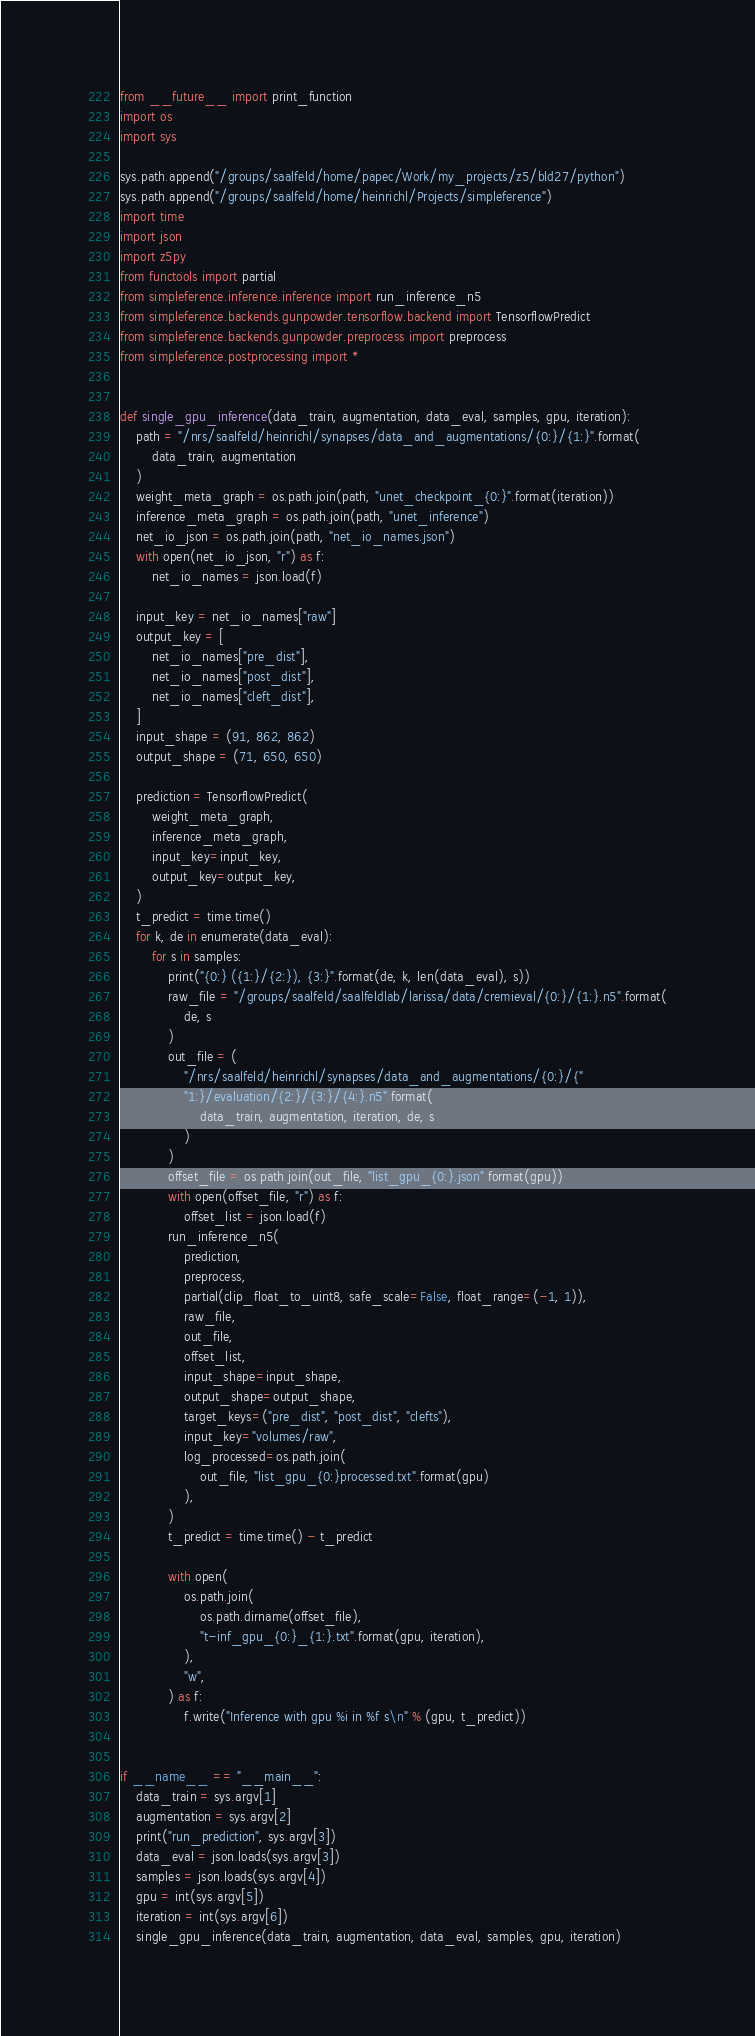<code> <loc_0><loc_0><loc_500><loc_500><_Python_>from __future__ import print_function
import os
import sys

sys.path.append("/groups/saalfeld/home/papec/Work/my_projects/z5/bld27/python")
sys.path.append("/groups/saalfeld/home/heinrichl/Projects/simpleference")
import time
import json
import z5py
from functools import partial
from simpleference.inference.inference import run_inference_n5
from simpleference.backends.gunpowder.tensorflow.backend import TensorflowPredict
from simpleference.backends.gunpowder.preprocess import preprocess
from simpleference.postprocessing import *


def single_gpu_inference(data_train, augmentation, data_eval, samples, gpu, iteration):
    path = "/nrs/saalfeld/heinrichl/synapses/data_and_augmentations/{0:}/{1:}".format(
        data_train, augmentation
    )
    weight_meta_graph = os.path.join(path, "unet_checkpoint_{0:}".format(iteration))
    inference_meta_graph = os.path.join(path, "unet_inference")
    net_io_json = os.path.join(path, "net_io_names.json")
    with open(net_io_json, "r") as f:
        net_io_names = json.load(f)

    input_key = net_io_names["raw"]
    output_key = [
        net_io_names["pre_dist"],
        net_io_names["post_dist"],
        net_io_names["cleft_dist"],
    ]
    input_shape = (91, 862, 862)
    output_shape = (71, 650, 650)

    prediction = TensorflowPredict(
        weight_meta_graph,
        inference_meta_graph,
        input_key=input_key,
        output_key=output_key,
    )
    t_predict = time.time()
    for k, de in enumerate(data_eval):
        for s in samples:
            print("{0:} ({1:}/{2:}), {3:}".format(de, k, len(data_eval), s))
            raw_file = "/groups/saalfeld/saalfeldlab/larissa/data/cremieval/{0:}/{1:}.n5".format(
                de, s
            )
            out_file = (
                "/nrs/saalfeld/heinrichl/synapses/data_and_augmentations/{0:}/{"
                "1:}/evaluation/{2:}/{3:}/{4:}.n5".format(
                    data_train, augmentation, iteration, de, s
                )
            )
            offset_file = os.path.join(out_file, "list_gpu_{0:}.json".format(gpu))
            with open(offset_file, "r") as f:
                offset_list = json.load(f)
            run_inference_n5(
                prediction,
                preprocess,
                partial(clip_float_to_uint8, safe_scale=False, float_range=(-1, 1)),
                raw_file,
                out_file,
                offset_list,
                input_shape=input_shape,
                output_shape=output_shape,
                target_keys=("pre_dist", "post_dist", "clefts"),
                input_key="volumes/raw",
                log_processed=os.path.join(
                    out_file, "list_gpu_{0:}processed.txt".format(gpu)
                ),
            )
            t_predict = time.time() - t_predict

            with open(
                os.path.join(
                    os.path.dirname(offset_file),
                    "t-inf_gpu_{0:}_{1:}.txt".format(gpu, iteration),
                ),
                "w",
            ) as f:
                f.write("Inference with gpu %i in %f s\n" % (gpu, t_predict))


if __name__ == "__main__":
    data_train = sys.argv[1]
    augmentation = sys.argv[2]
    print("run_prediction", sys.argv[3])
    data_eval = json.loads(sys.argv[3])
    samples = json.loads(sys.argv[4])
    gpu = int(sys.argv[5])
    iteration = int(sys.argv[6])
    single_gpu_inference(data_train, augmentation, data_eval, samples, gpu, iteration)
</code> 